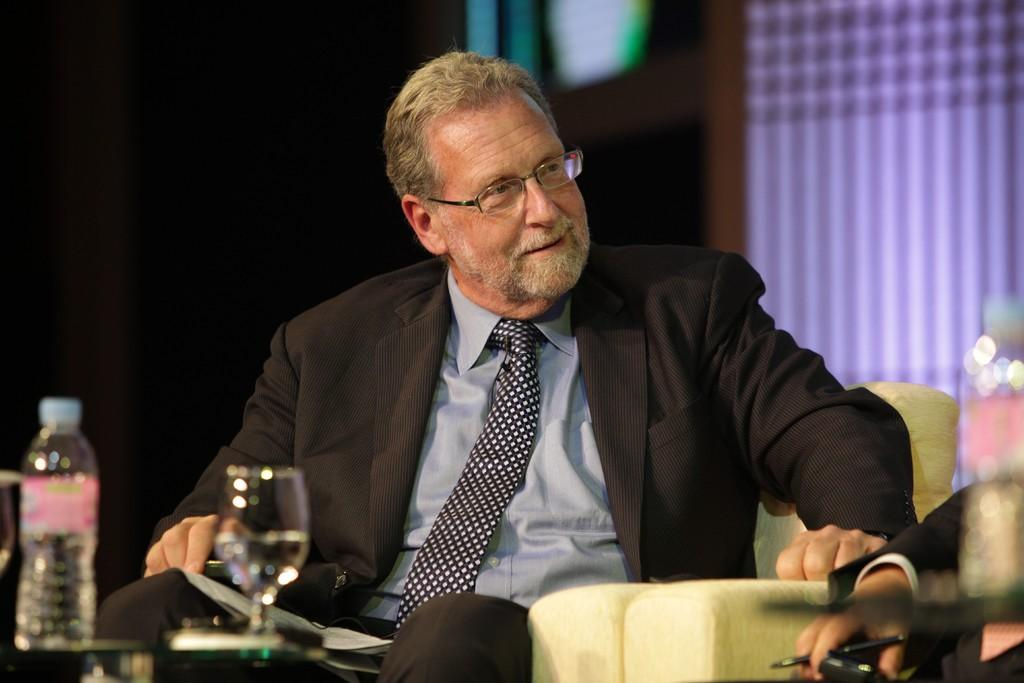What is the person in the image doing? The person is sitting on a chair in the image. What objects can be seen near the person? There is a water bottle and a glass in the image. What type of pickle is the person holding in the image? There is no pickle present in the image. What kind of shop can be seen in the background of the image? There is no shop visible in the image; it only shows a person sitting on a chair with a water bottle and a glass nearby. 